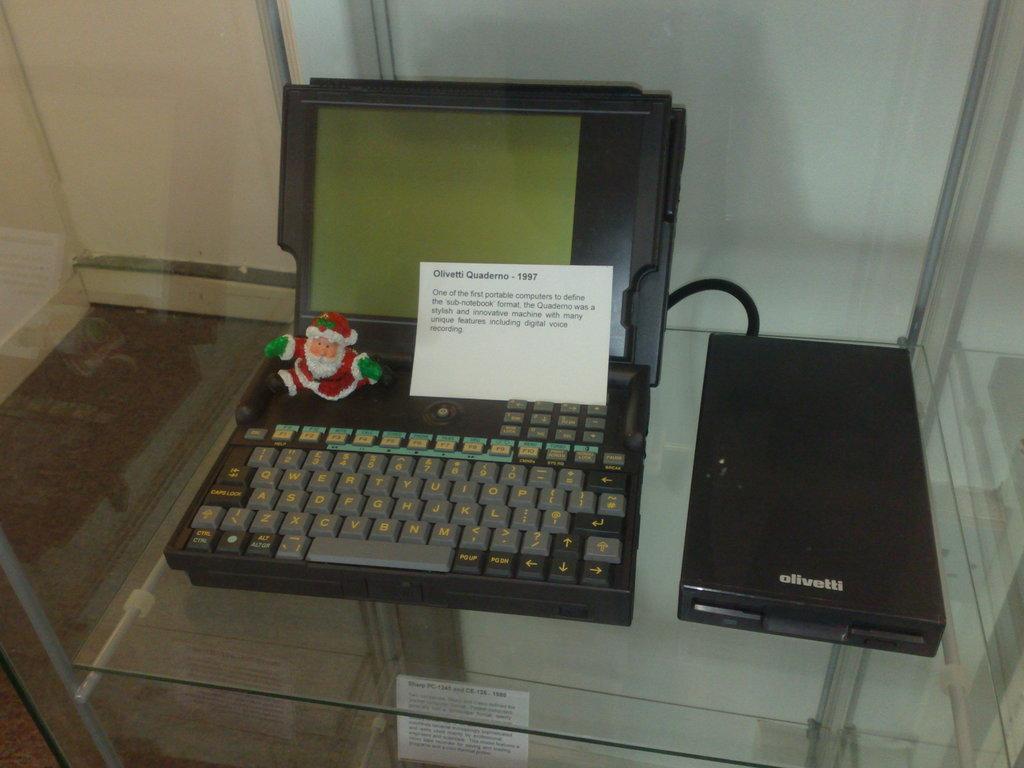What is the year on the text label?
Your response must be concise. 1997. 